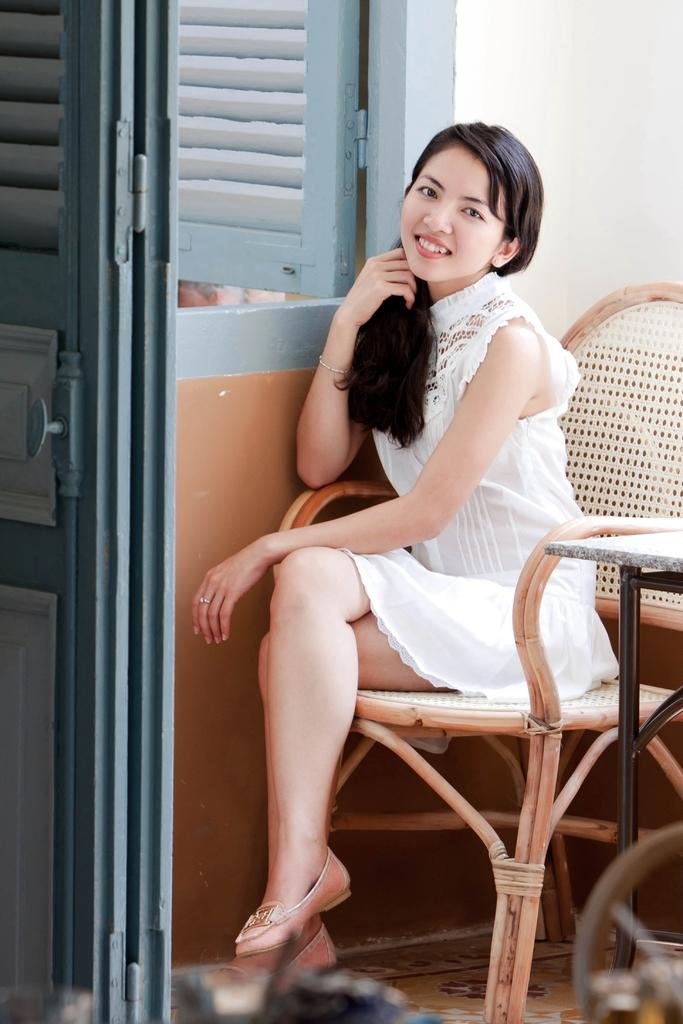Who is the main subject in the image? There is a girl in the image. What is the girl doing in the image? The girl is sitting on a chair. Where is the chair located in relation to other objects in the image? The chair is near a door. What other furniture can be seen in the image? There is a table in the image. What direction is the wind blowing in the image? There is no mention of wind in the image, so it cannot be determined which direction the wind is blowing. 